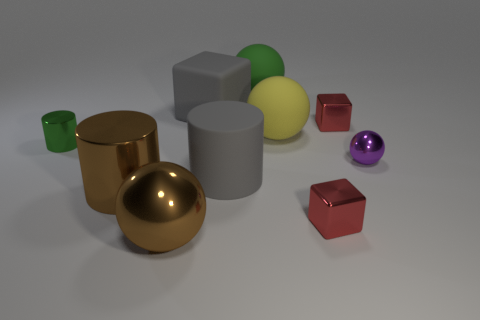Subtract all cylinders. How many objects are left? 7 Subtract 1 green cylinders. How many objects are left? 9 Subtract all large brown metallic cylinders. Subtract all big matte cylinders. How many objects are left? 8 Add 1 rubber cubes. How many rubber cubes are left? 2 Add 3 shiny cubes. How many shiny cubes exist? 5 